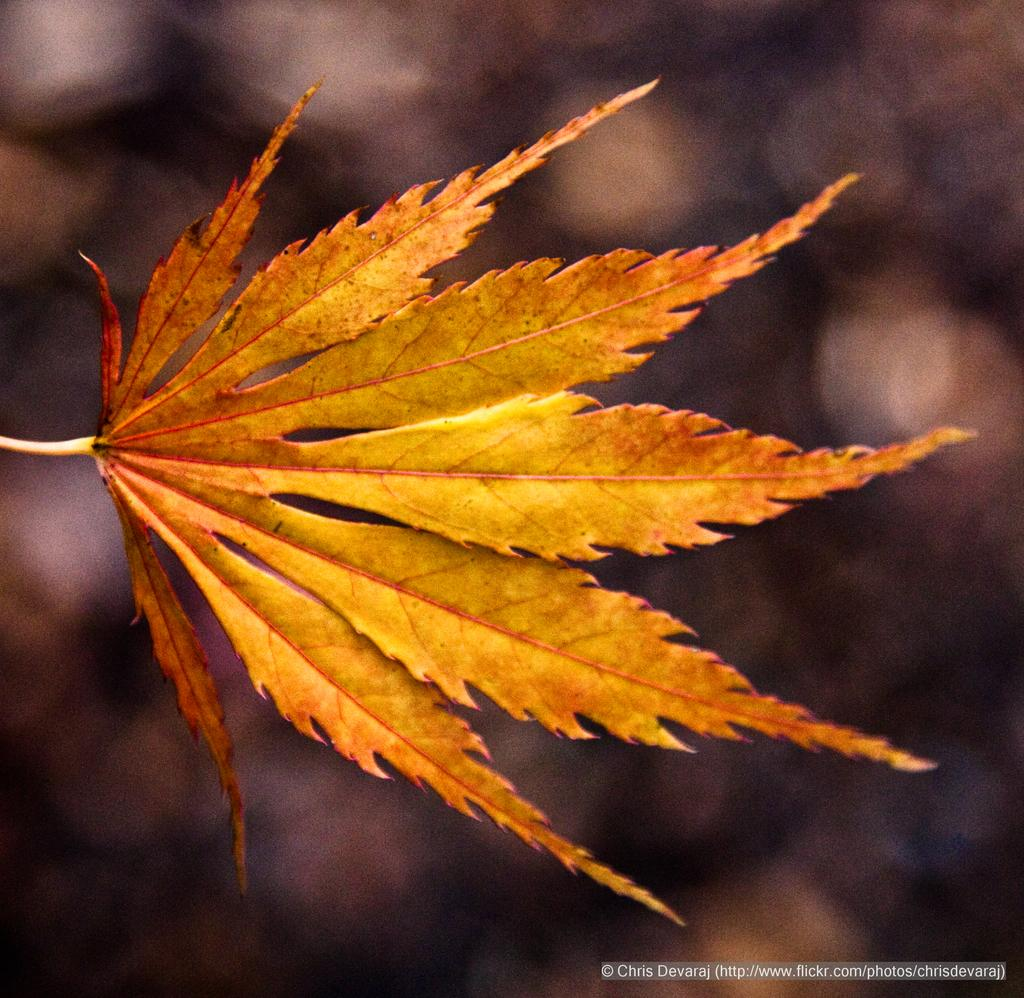What type of vegetation is present in the front of the image? There are leaves in the front of the image. How would you describe the background of the image? The background of the image is blurry. Where can text be found in the image? Text is visible at the bottom right of the image. What nation is represented by the leaves in the image? The leaves in the image do not represent any nation; they are simply a type of vegetation. What thing is being acted upon in the image? There is no specific thing being acted upon in the image; it primarily features leaves and a blurry background. 